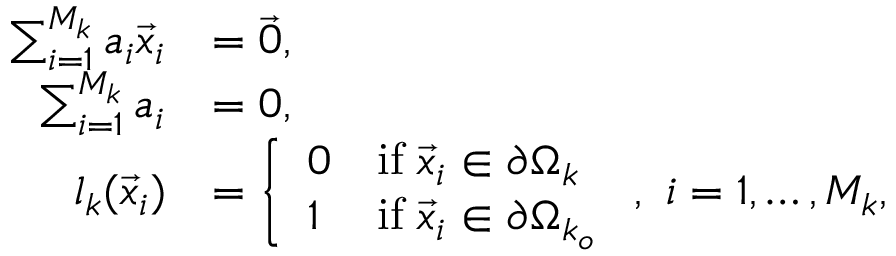Convert formula to latex. <formula><loc_0><loc_0><loc_500><loc_500>\begin{array} { r l } { \sum _ { i = 1 } ^ { M _ { k } } a _ { i } \vec { x } _ { i } } & { = \vec { 0 } , } \\ { \sum _ { i = 1 } ^ { M _ { k } } a _ { i } } & { = 0 , } \\ { l _ { k } ( \vec { x } _ { i } ) } & { = \left \{ \begin{array} { l l } { 0 } & { i f \, \vec { x } _ { i } \in \partial \Omega _ { k } } \\ { 1 } & { i f \, \vec { x } _ { i } \in \partial \Omega _ { k _ { o } } } \end{array} , \, i = 1 , \dots , M _ { k } , } \end{array}</formula> 